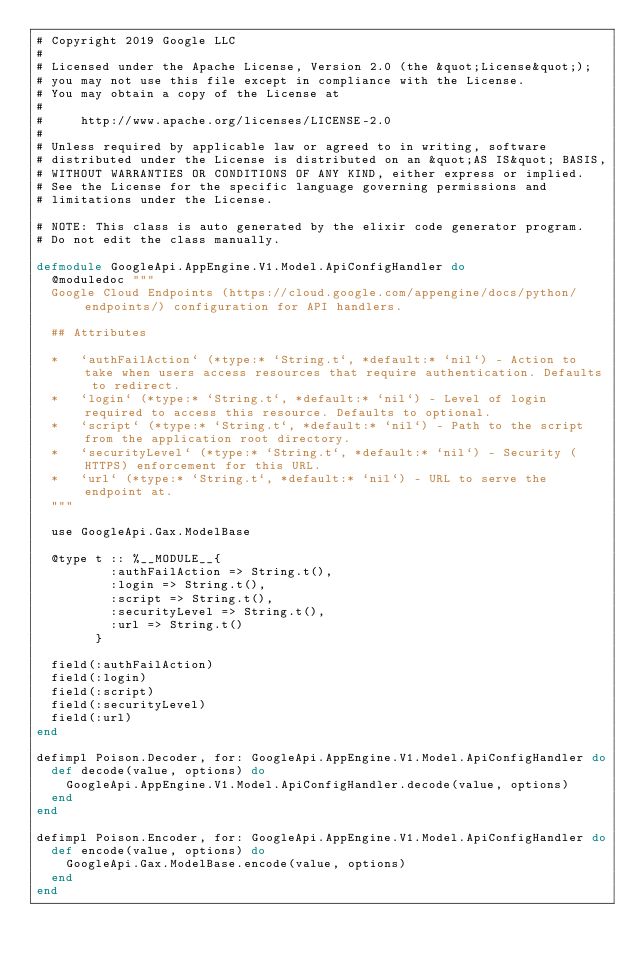Convert code to text. <code><loc_0><loc_0><loc_500><loc_500><_Elixir_># Copyright 2019 Google LLC
#
# Licensed under the Apache License, Version 2.0 (the &quot;License&quot;);
# you may not use this file except in compliance with the License.
# You may obtain a copy of the License at
#
#     http://www.apache.org/licenses/LICENSE-2.0
#
# Unless required by applicable law or agreed to in writing, software
# distributed under the License is distributed on an &quot;AS IS&quot; BASIS,
# WITHOUT WARRANTIES OR CONDITIONS OF ANY KIND, either express or implied.
# See the License for the specific language governing permissions and
# limitations under the License.

# NOTE: This class is auto generated by the elixir code generator program.
# Do not edit the class manually.

defmodule GoogleApi.AppEngine.V1.Model.ApiConfigHandler do
  @moduledoc """
  Google Cloud Endpoints (https://cloud.google.com/appengine/docs/python/endpoints/) configuration for API handlers.

  ## Attributes

  *   `authFailAction` (*type:* `String.t`, *default:* `nil`) - Action to take when users access resources that require authentication. Defaults to redirect.
  *   `login` (*type:* `String.t`, *default:* `nil`) - Level of login required to access this resource. Defaults to optional.
  *   `script` (*type:* `String.t`, *default:* `nil`) - Path to the script from the application root directory.
  *   `securityLevel` (*type:* `String.t`, *default:* `nil`) - Security (HTTPS) enforcement for this URL.
  *   `url` (*type:* `String.t`, *default:* `nil`) - URL to serve the endpoint at.
  """

  use GoogleApi.Gax.ModelBase

  @type t :: %__MODULE__{
          :authFailAction => String.t(),
          :login => String.t(),
          :script => String.t(),
          :securityLevel => String.t(),
          :url => String.t()
        }

  field(:authFailAction)
  field(:login)
  field(:script)
  field(:securityLevel)
  field(:url)
end

defimpl Poison.Decoder, for: GoogleApi.AppEngine.V1.Model.ApiConfigHandler do
  def decode(value, options) do
    GoogleApi.AppEngine.V1.Model.ApiConfigHandler.decode(value, options)
  end
end

defimpl Poison.Encoder, for: GoogleApi.AppEngine.V1.Model.ApiConfigHandler do
  def encode(value, options) do
    GoogleApi.Gax.ModelBase.encode(value, options)
  end
end
</code> 